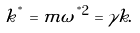Convert formula to latex. <formula><loc_0><loc_0><loc_500><loc_500>k ^ { ^ { * } } = m \omega ^ { ^ { * } 2 } = \gamma k .</formula> 